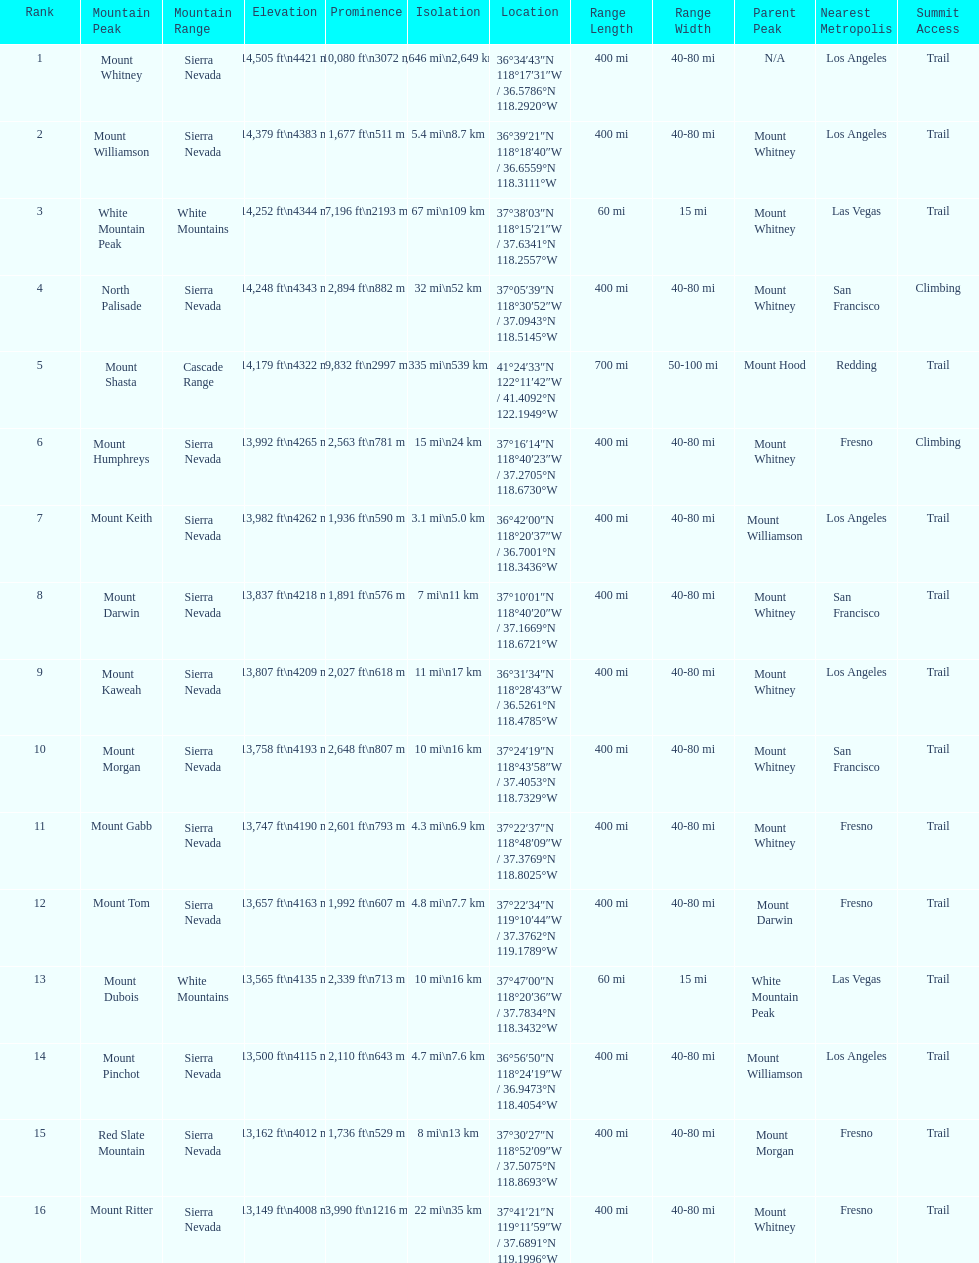How much taller is the mountain peak of mount williamson than that of mount keith? 397 ft. 